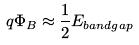<formula> <loc_0><loc_0><loc_500><loc_500>q \Phi _ { B } \approx \frac { 1 } { 2 } E _ { b a n d g a p }</formula> 